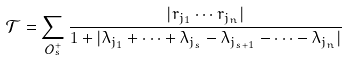Convert formula to latex. <formula><loc_0><loc_0><loc_500><loc_500>\mathcal { T } = \sum _ { \mathcal { O } _ { s } ^ { + } } \frac { | r _ { j _ { 1 } } \cdots r _ { j _ { n } } | } { 1 + | \lambda _ { j _ { 1 } } + \cdots + \lambda _ { j _ { s } } - \lambda _ { j _ { s + 1 } } - \cdots - \lambda _ { j _ { n } } | }</formula> 